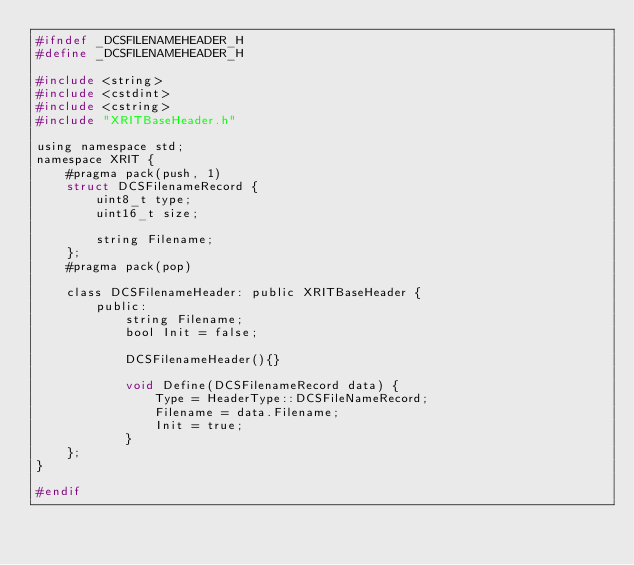Convert code to text. <code><loc_0><loc_0><loc_500><loc_500><_C_>#ifndef _DCSFILENAMEHEADER_H
#define _DCSFILENAMEHEADER_H

#include <string>
#include <cstdint>
#include <cstring>
#include "XRITBaseHeader.h"

using namespace std;
namespace XRIT {
    #pragma pack(push, 1)
    struct DCSFilenameRecord {
        uint8_t type;
        uint16_t size;
        
        string Filename;
    };
    #pragma pack(pop)

    class DCSFilenameHeader: public XRITBaseHeader {
        public:
            string Filename;
            bool Init = false;
            
            DCSFilenameHeader(){}

            void Define(DCSFilenameRecord data) {
                Type = HeaderType::DCSFileNameRecord;
                Filename = data.Filename;
                Init = true;
            }
    };
}

#endif</code> 